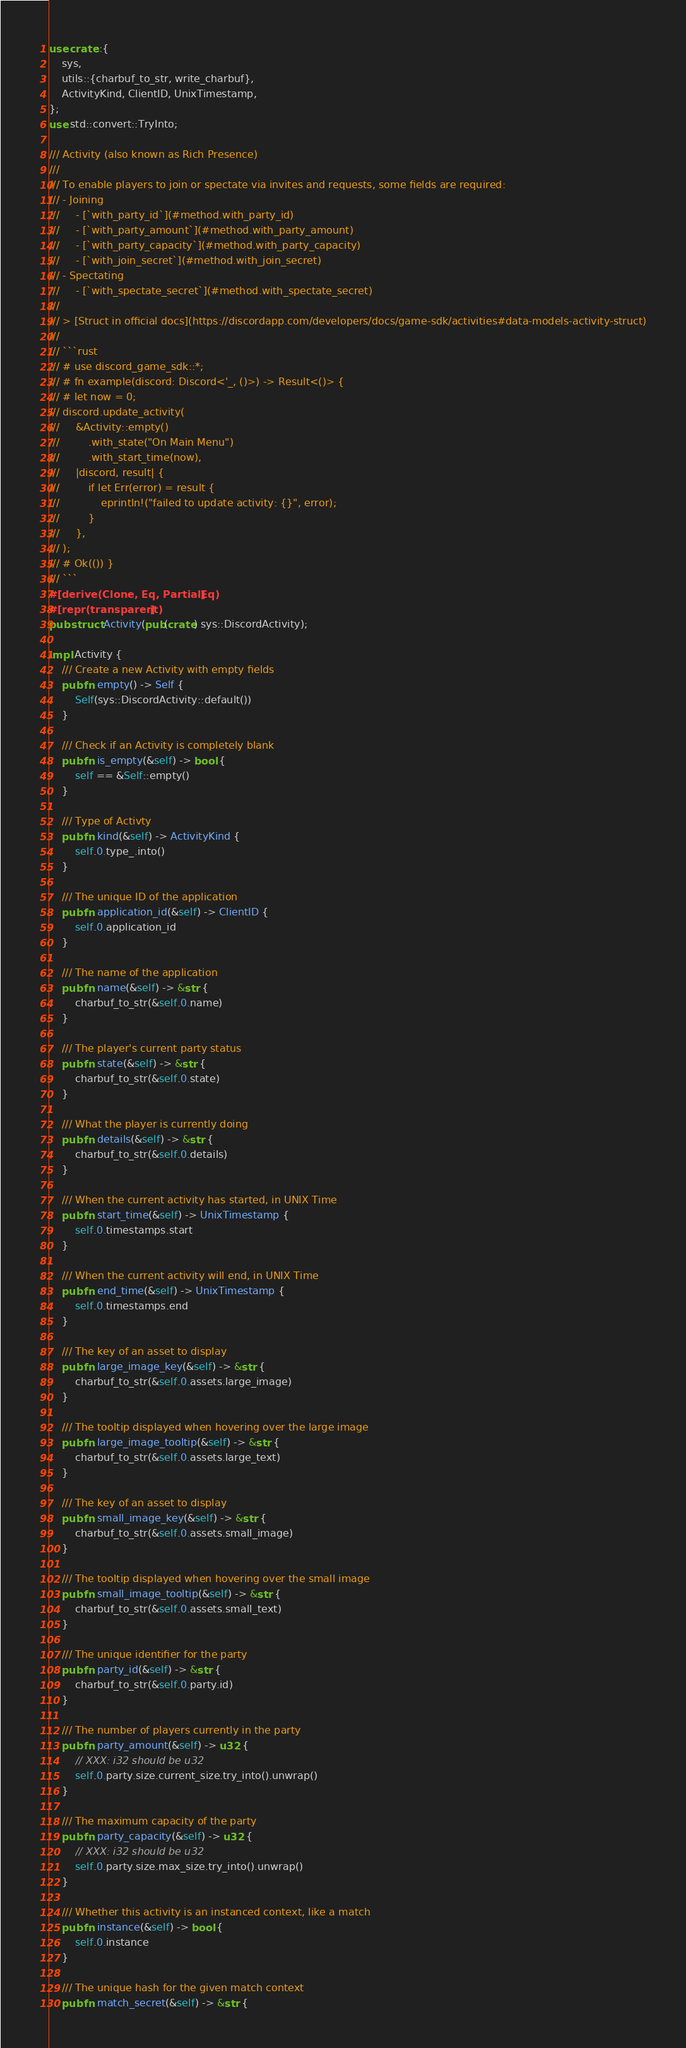<code> <loc_0><loc_0><loc_500><loc_500><_Rust_>use crate::{
    sys,
    utils::{charbuf_to_str, write_charbuf},
    ActivityKind, ClientID, UnixTimestamp,
};
use std::convert::TryInto;

/// Activity (also known as Rich Presence)
///
/// To enable players to join or spectate via invites and requests, some fields are required:
/// - Joining
///     - [`with_party_id`](#method.with_party_id)
///     - [`with_party_amount`](#method.with_party_amount)
///     - [`with_party_capacity`](#method.with_party_capacity)
///     - [`with_join_secret`](#method.with_join_secret)
/// - Spectating
///     - [`with_spectate_secret`](#method.with_spectate_secret)
///
/// > [Struct in official docs](https://discordapp.com/developers/docs/game-sdk/activities#data-models-activity-struct)
///
/// ```rust
/// # use discord_game_sdk::*;
/// # fn example(discord: Discord<'_, ()>) -> Result<()> {
/// # let now = 0;
/// discord.update_activity(
///     &Activity::empty()
///         .with_state("On Main Menu")
///         .with_start_time(now),
///     |discord, result| {
///         if let Err(error) = result {
///             eprintln!("failed to update activity: {}", error);
///         }
///     },
/// );
/// # Ok(()) }
/// ```
#[derive(Clone, Eq, PartialEq)]
#[repr(transparent)]
pub struct Activity(pub(crate) sys::DiscordActivity);

impl Activity {
    /// Create a new Activity with empty fields
    pub fn empty() -> Self {
        Self(sys::DiscordActivity::default())
    }

    /// Check if an Activity is completely blank
    pub fn is_empty(&self) -> bool {
        self == &Self::empty()
    }

    /// Type of Activty
    pub fn kind(&self) -> ActivityKind {
        self.0.type_.into()
    }

    /// The unique ID of the application
    pub fn application_id(&self) -> ClientID {
        self.0.application_id
    }

    /// The name of the application
    pub fn name(&self) -> &str {
        charbuf_to_str(&self.0.name)
    }

    /// The player's current party status
    pub fn state(&self) -> &str {
        charbuf_to_str(&self.0.state)
    }

    /// What the player is currently doing
    pub fn details(&self) -> &str {
        charbuf_to_str(&self.0.details)
    }

    /// When the current activity has started, in UNIX Time
    pub fn start_time(&self) -> UnixTimestamp {
        self.0.timestamps.start
    }

    /// When the current activity will end, in UNIX Time
    pub fn end_time(&self) -> UnixTimestamp {
        self.0.timestamps.end
    }

    /// The key of an asset to display
    pub fn large_image_key(&self) -> &str {
        charbuf_to_str(&self.0.assets.large_image)
    }

    /// The tooltip displayed when hovering over the large image
    pub fn large_image_tooltip(&self) -> &str {
        charbuf_to_str(&self.0.assets.large_text)
    }

    /// The key of an asset to display
    pub fn small_image_key(&self) -> &str {
        charbuf_to_str(&self.0.assets.small_image)
    }

    /// The tooltip displayed when hovering over the small image
    pub fn small_image_tooltip(&self) -> &str {
        charbuf_to_str(&self.0.assets.small_text)
    }

    /// The unique identifier for the party
    pub fn party_id(&self) -> &str {
        charbuf_to_str(&self.0.party.id)
    }

    /// The number of players currently in the party
    pub fn party_amount(&self) -> u32 {
        // XXX: i32 should be u32
        self.0.party.size.current_size.try_into().unwrap()
    }

    /// The maximum capacity of the party
    pub fn party_capacity(&self) -> u32 {
        // XXX: i32 should be u32
        self.0.party.size.max_size.try_into().unwrap()
    }

    /// Whether this activity is an instanced context, like a match
    pub fn instance(&self) -> bool {
        self.0.instance
    }

    /// The unique hash for the given match context
    pub fn match_secret(&self) -> &str {</code> 